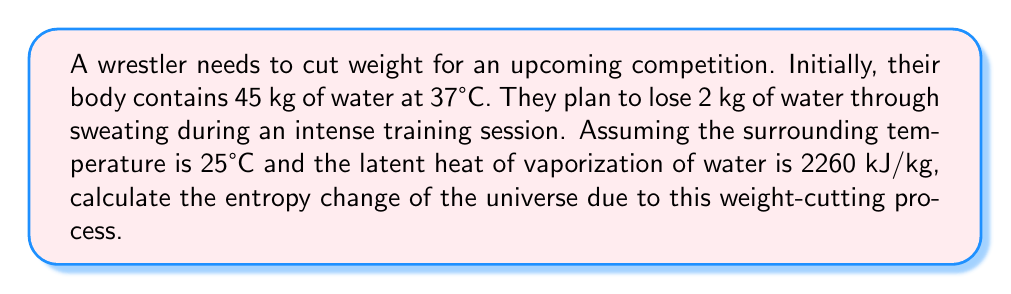Could you help me with this problem? Let's approach this step-by-step:

1) First, we need to calculate the heat transferred during the process. This is equal to the energy required to vaporize 2 kg of water:

   $Q = mL_v = 2 \text{ kg} \times 2260 \text{ kJ/kg} = 4520 \text{ kJ}$

2) The entropy change of the universe is the sum of the entropy change of the system (the wrestler's body) and the surroundings:

   $\Delta S_{universe} = \Delta S_{system} + \Delta S_{surroundings}$

3) For the system, we need to calculate the entropy change due to the loss of 2 kg of water:

   $\Delta S_{system} = -\frac{m_{\text{lost}}}{m_{\text{initial}}} \cdot S_{\text{water}}$

   Where $S_{\text{water}}$ is the specific entropy of water at 37°C, which is approximately 3.96 kJ/(kg·K).

   $\Delta S_{system} = -\frac{2 \text{ kg}}{45 \text{ kg}} \times 3.96 \text{ kJ/(kg·K)} = -0.176 \text{ kJ/K}$

4) For the surroundings, we calculate the entropy change due to the heat transfer:

   $\Delta S_{surroundings} = \frac{Q}{T} = \frac{4520 \text{ kJ}}{298 \text{ K}} = 15.168 \text{ kJ/K}$

5) Now we can calculate the total entropy change:

   $\Delta S_{universe} = \Delta S_{system} + \Delta S_{surroundings}$
   $\Delta S_{universe} = -0.176 \text{ kJ/K} + 15.168 \text{ kJ/K} = 14.992 \text{ kJ/K}$
Answer: 14.992 kJ/K 